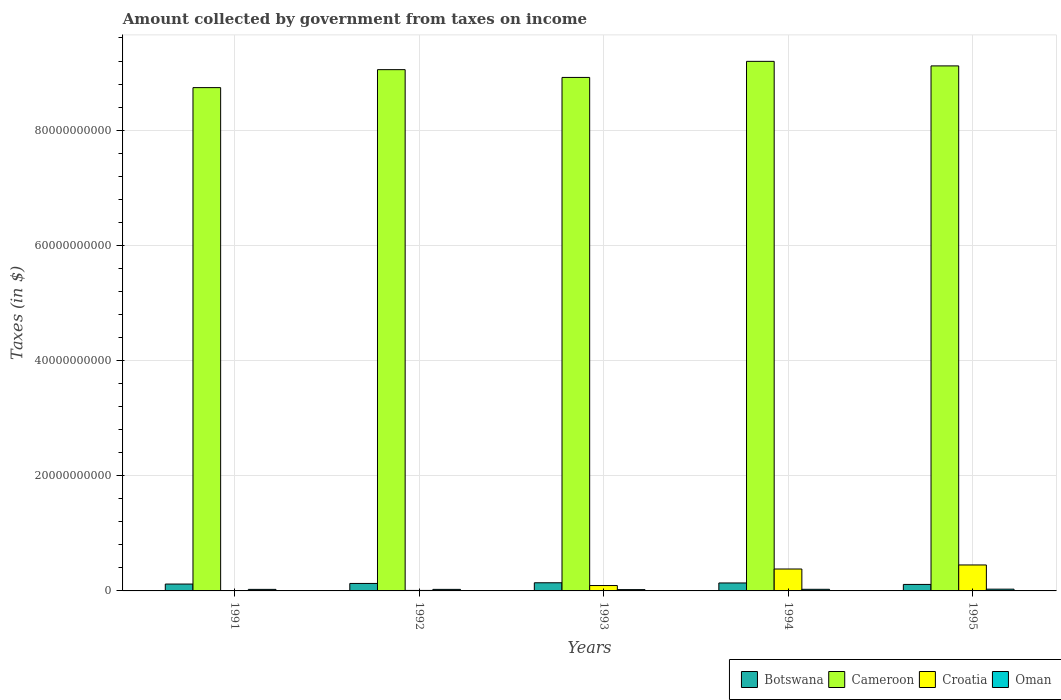How many different coloured bars are there?
Give a very brief answer. 4. Are the number of bars on each tick of the X-axis equal?
Provide a succinct answer. Yes. What is the label of the 1st group of bars from the left?
Ensure brevity in your answer.  1991. In how many cases, is the number of bars for a given year not equal to the number of legend labels?
Provide a short and direct response. 0. What is the amount collected by government from taxes on income in Cameroon in 1995?
Provide a short and direct response. 9.12e+1. Across all years, what is the maximum amount collected by government from taxes on income in Croatia?
Your response must be concise. 4.51e+09. Across all years, what is the minimum amount collected by government from taxes on income in Croatia?
Your answer should be very brief. 2.45e+07. In which year was the amount collected by government from taxes on income in Croatia maximum?
Provide a succinct answer. 1995. In which year was the amount collected by government from taxes on income in Cameroon minimum?
Offer a very short reply. 1991. What is the total amount collected by government from taxes on income in Botswana in the graph?
Offer a very short reply. 6.41e+09. What is the difference between the amount collected by government from taxes on income in Botswana in 1991 and that in 1994?
Provide a succinct answer. -1.90e+08. What is the difference between the amount collected by government from taxes on income in Croatia in 1993 and the amount collected by government from taxes on income in Cameroon in 1995?
Keep it short and to the point. -9.02e+1. What is the average amount collected by government from taxes on income in Oman per year?
Give a very brief answer. 2.70e+08. In the year 1992, what is the difference between the amount collected by government from taxes on income in Botswana and amount collected by government from taxes on income in Cameroon?
Your answer should be very brief. -8.92e+1. In how many years, is the amount collected by government from taxes on income in Cameroon greater than 12000000000 $?
Your answer should be very brief. 5. What is the ratio of the amount collected by government from taxes on income in Oman in 1992 to that in 1993?
Provide a succinct answer. 1.18. Is the difference between the amount collected by government from taxes on income in Botswana in 1992 and 1993 greater than the difference between the amount collected by government from taxes on income in Cameroon in 1992 and 1993?
Offer a terse response. No. What is the difference between the highest and the second highest amount collected by government from taxes on income in Oman?
Offer a terse response. 2.39e+07. What is the difference between the highest and the lowest amount collected by government from taxes on income in Botswana?
Make the answer very short. 2.88e+08. In how many years, is the amount collected by government from taxes on income in Botswana greater than the average amount collected by government from taxes on income in Botswana taken over all years?
Provide a succinct answer. 3. Is the sum of the amount collected by government from taxes on income in Botswana in 1992 and 1994 greater than the maximum amount collected by government from taxes on income in Cameroon across all years?
Give a very brief answer. No. What does the 4th bar from the left in 1991 represents?
Your answer should be compact. Oman. What does the 3rd bar from the right in 1995 represents?
Your response must be concise. Cameroon. Are all the bars in the graph horizontal?
Offer a terse response. No. How many years are there in the graph?
Offer a very short reply. 5. Are the values on the major ticks of Y-axis written in scientific E-notation?
Make the answer very short. No. Does the graph contain grids?
Offer a very short reply. Yes. How many legend labels are there?
Ensure brevity in your answer.  4. How are the legend labels stacked?
Make the answer very short. Horizontal. What is the title of the graph?
Make the answer very short. Amount collected by government from taxes on income. Does "Greece" appear as one of the legend labels in the graph?
Your answer should be compact. No. What is the label or title of the Y-axis?
Offer a very short reply. Taxes (in $). What is the Taxes (in $) in Botswana in 1991?
Keep it short and to the point. 1.19e+09. What is the Taxes (in $) of Cameroon in 1991?
Provide a short and direct response. 8.74e+1. What is the Taxes (in $) in Croatia in 1991?
Provide a short and direct response. 2.45e+07. What is the Taxes (in $) of Oman in 1991?
Offer a terse response. 2.67e+08. What is the Taxes (in $) in Botswana in 1992?
Offer a terse response. 1.30e+09. What is the Taxes (in $) in Cameroon in 1992?
Provide a succinct answer. 9.05e+1. What is the Taxes (in $) in Croatia in 1992?
Make the answer very short. 8.40e+07. What is the Taxes (in $) in Oman in 1992?
Provide a short and direct response. 2.67e+08. What is the Taxes (in $) in Botswana in 1993?
Keep it short and to the point. 1.42e+09. What is the Taxes (in $) in Cameroon in 1993?
Your answer should be very brief. 8.92e+1. What is the Taxes (in $) in Croatia in 1993?
Give a very brief answer. 9.36e+08. What is the Taxes (in $) in Oman in 1993?
Keep it short and to the point. 2.27e+08. What is the Taxes (in $) of Botswana in 1994?
Ensure brevity in your answer.  1.38e+09. What is the Taxes (in $) of Cameroon in 1994?
Give a very brief answer. 9.19e+1. What is the Taxes (in $) in Croatia in 1994?
Keep it short and to the point. 3.80e+09. What is the Taxes (in $) of Oman in 1994?
Keep it short and to the point. 2.82e+08. What is the Taxes (in $) in Botswana in 1995?
Provide a succinct answer. 1.13e+09. What is the Taxes (in $) of Cameroon in 1995?
Give a very brief answer. 9.12e+1. What is the Taxes (in $) of Croatia in 1995?
Provide a succinct answer. 4.51e+09. What is the Taxes (in $) in Oman in 1995?
Your response must be concise. 3.06e+08. Across all years, what is the maximum Taxes (in $) in Botswana?
Keep it short and to the point. 1.42e+09. Across all years, what is the maximum Taxes (in $) of Cameroon?
Keep it short and to the point. 9.19e+1. Across all years, what is the maximum Taxes (in $) of Croatia?
Ensure brevity in your answer.  4.51e+09. Across all years, what is the maximum Taxes (in $) of Oman?
Provide a short and direct response. 3.06e+08. Across all years, what is the minimum Taxes (in $) of Botswana?
Your answer should be compact. 1.13e+09. Across all years, what is the minimum Taxes (in $) of Cameroon?
Offer a terse response. 8.74e+1. Across all years, what is the minimum Taxes (in $) in Croatia?
Your response must be concise. 2.45e+07. Across all years, what is the minimum Taxes (in $) of Oman?
Offer a very short reply. 2.27e+08. What is the total Taxes (in $) in Botswana in the graph?
Ensure brevity in your answer.  6.41e+09. What is the total Taxes (in $) of Cameroon in the graph?
Give a very brief answer. 4.50e+11. What is the total Taxes (in $) in Croatia in the graph?
Keep it short and to the point. 9.35e+09. What is the total Taxes (in $) of Oman in the graph?
Make the answer very short. 1.35e+09. What is the difference between the Taxes (in $) in Botswana in 1991 and that in 1992?
Offer a very short reply. -1.07e+08. What is the difference between the Taxes (in $) in Cameroon in 1991 and that in 1992?
Offer a very short reply. -3.12e+09. What is the difference between the Taxes (in $) in Croatia in 1991 and that in 1992?
Keep it short and to the point. -5.95e+07. What is the difference between the Taxes (in $) of Oman in 1991 and that in 1992?
Provide a succinct answer. 2.00e+05. What is the difference between the Taxes (in $) in Botswana in 1991 and that in 1993?
Offer a very short reply. -2.24e+08. What is the difference between the Taxes (in $) in Cameroon in 1991 and that in 1993?
Provide a succinct answer. -1.77e+09. What is the difference between the Taxes (in $) of Croatia in 1991 and that in 1993?
Make the answer very short. -9.11e+08. What is the difference between the Taxes (in $) in Oman in 1991 and that in 1993?
Give a very brief answer. 4.00e+07. What is the difference between the Taxes (in $) in Botswana in 1991 and that in 1994?
Provide a short and direct response. -1.90e+08. What is the difference between the Taxes (in $) of Cameroon in 1991 and that in 1994?
Offer a very short reply. -4.56e+09. What is the difference between the Taxes (in $) in Croatia in 1991 and that in 1994?
Keep it short and to the point. -3.78e+09. What is the difference between the Taxes (in $) in Oman in 1991 and that in 1994?
Make the answer very short. -1.43e+07. What is the difference between the Taxes (in $) in Botswana in 1991 and that in 1995?
Keep it short and to the point. 6.38e+07. What is the difference between the Taxes (in $) of Cameroon in 1991 and that in 1995?
Keep it short and to the point. -3.77e+09. What is the difference between the Taxes (in $) of Croatia in 1991 and that in 1995?
Your response must be concise. -4.48e+09. What is the difference between the Taxes (in $) of Oman in 1991 and that in 1995?
Give a very brief answer. -3.82e+07. What is the difference between the Taxes (in $) of Botswana in 1992 and that in 1993?
Ensure brevity in your answer.  -1.18e+08. What is the difference between the Taxes (in $) in Cameroon in 1992 and that in 1993?
Your answer should be very brief. 1.35e+09. What is the difference between the Taxes (in $) of Croatia in 1992 and that in 1993?
Provide a short and direct response. -8.52e+08. What is the difference between the Taxes (in $) in Oman in 1992 and that in 1993?
Your response must be concise. 3.98e+07. What is the difference between the Taxes (in $) of Botswana in 1992 and that in 1994?
Provide a succinct answer. -8.36e+07. What is the difference between the Taxes (in $) of Cameroon in 1992 and that in 1994?
Ensure brevity in your answer.  -1.44e+09. What is the difference between the Taxes (in $) in Croatia in 1992 and that in 1994?
Your response must be concise. -3.72e+09. What is the difference between the Taxes (in $) of Oman in 1992 and that in 1994?
Ensure brevity in your answer.  -1.45e+07. What is the difference between the Taxes (in $) in Botswana in 1992 and that in 1995?
Give a very brief answer. 1.70e+08. What is the difference between the Taxes (in $) of Cameroon in 1992 and that in 1995?
Give a very brief answer. -6.50e+08. What is the difference between the Taxes (in $) of Croatia in 1992 and that in 1995?
Keep it short and to the point. -4.42e+09. What is the difference between the Taxes (in $) of Oman in 1992 and that in 1995?
Offer a very short reply. -3.84e+07. What is the difference between the Taxes (in $) in Botswana in 1993 and that in 1994?
Your answer should be very brief. 3.42e+07. What is the difference between the Taxes (in $) of Cameroon in 1993 and that in 1994?
Make the answer very short. -2.79e+09. What is the difference between the Taxes (in $) of Croatia in 1993 and that in 1994?
Your answer should be very brief. -2.87e+09. What is the difference between the Taxes (in $) in Oman in 1993 and that in 1994?
Ensure brevity in your answer.  -5.43e+07. What is the difference between the Taxes (in $) of Botswana in 1993 and that in 1995?
Your answer should be compact. 2.88e+08. What is the difference between the Taxes (in $) of Cameroon in 1993 and that in 1995?
Ensure brevity in your answer.  -2.00e+09. What is the difference between the Taxes (in $) of Croatia in 1993 and that in 1995?
Ensure brevity in your answer.  -3.57e+09. What is the difference between the Taxes (in $) of Oman in 1993 and that in 1995?
Give a very brief answer. -7.82e+07. What is the difference between the Taxes (in $) in Botswana in 1994 and that in 1995?
Make the answer very short. 2.54e+08. What is the difference between the Taxes (in $) in Cameroon in 1994 and that in 1995?
Provide a short and direct response. 7.90e+08. What is the difference between the Taxes (in $) in Croatia in 1994 and that in 1995?
Your answer should be very brief. -7.03e+08. What is the difference between the Taxes (in $) in Oman in 1994 and that in 1995?
Provide a succinct answer. -2.39e+07. What is the difference between the Taxes (in $) of Botswana in 1991 and the Taxes (in $) of Cameroon in 1992?
Keep it short and to the point. -8.93e+1. What is the difference between the Taxes (in $) in Botswana in 1991 and the Taxes (in $) in Croatia in 1992?
Make the answer very short. 1.11e+09. What is the difference between the Taxes (in $) of Botswana in 1991 and the Taxes (in $) of Oman in 1992?
Your answer should be compact. 9.24e+08. What is the difference between the Taxes (in $) of Cameroon in 1991 and the Taxes (in $) of Croatia in 1992?
Your response must be concise. 8.73e+1. What is the difference between the Taxes (in $) in Cameroon in 1991 and the Taxes (in $) in Oman in 1992?
Your answer should be compact. 8.71e+1. What is the difference between the Taxes (in $) of Croatia in 1991 and the Taxes (in $) of Oman in 1992?
Your answer should be very brief. -2.43e+08. What is the difference between the Taxes (in $) of Botswana in 1991 and the Taxes (in $) of Cameroon in 1993?
Keep it short and to the point. -8.80e+1. What is the difference between the Taxes (in $) in Botswana in 1991 and the Taxes (in $) in Croatia in 1993?
Ensure brevity in your answer.  2.55e+08. What is the difference between the Taxes (in $) of Botswana in 1991 and the Taxes (in $) of Oman in 1993?
Offer a terse response. 9.64e+08. What is the difference between the Taxes (in $) in Cameroon in 1991 and the Taxes (in $) in Croatia in 1993?
Your response must be concise. 8.64e+1. What is the difference between the Taxes (in $) of Cameroon in 1991 and the Taxes (in $) of Oman in 1993?
Give a very brief answer. 8.72e+1. What is the difference between the Taxes (in $) in Croatia in 1991 and the Taxes (in $) in Oman in 1993?
Ensure brevity in your answer.  -2.03e+08. What is the difference between the Taxes (in $) in Botswana in 1991 and the Taxes (in $) in Cameroon in 1994?
Provide a short and direct response. -9.07e+1. What is the difference between the Taxes (in $) in Botswana in 1991 and the Taxes (in $) in Croatia in 1994?
Make the answer very short. -2.61e+09. What is the difference between the Taxes (in $) in Botswana in 1991 and the Taxes (in $) in Oman in 1994?
Your response must be concise. 9.09e+08. What is the difference between the Taxes (in $) in Cameroon in 1991 and the Taxes (in $) in Croatia in 1994?
Your answer should be compact. 8.36e+1. What is the difference between the Taxes (in $) in Cameroon in 1991 and the Taxes (in $) in Oman in 1994?
Make the answer very short. 8.71e+1. What is the difference between the Taxes (in $) of Croatia in 1991 and the Taxes (in $) of Oman in 1994?
Give a very brief answer. -2.57e+08. What is the difference between the Taxes (in $) of Botswana in 1991 and the Taxes (in $) of Cameroon in 1995?
Your answer should be very brief. -9.00e+1. What is the difference between the Taxes (in $) of Botswana in 1991 and the Taxes (in $) of Croatia in 1995?
Offer a terse response. -3.32e+09. What is the difference between the Taxes (in $) of Botswana in 1991 and the Taxes (in $) of Oman in 1995?
Ensure brevity in your answer.  8.85e+08. What is the difference between the Taxes (in $) in Cameroon in 1991 and the Taxes (in $) in Croatia in 1995?
Offer a very short reply. 8.29e+1. What is the difference between the Taxes (in $) in Cameroon in 1991 and the Taxes (in $) in Oman in 1995?
Your response must be concise. 8.71e+1. What is the difference between the Taxes (in $) in Croatia in 1991 and the Taxes (in $) in Oman in 1995?
Offer a terse response. -2.81e+08. What is the difference between the Taxes (in $) of Botswana in 1992 and the Taxes (in $) of Cameroon in 1993?
Make the answer very short. -8.79e+1. What is the difference between the Taxes (in $) in Botswana in 1992 and the Taxes (in $) in Croatia in 1993?
Give a very brief answer. 3.62e+08. What is the difference between the Taxes (in $) of Botswana in 1992 and the Taxes (in $) of Oman in 1993?
Your response must be concise. 1.07e+09. What is the difference between the Taxes (in $) in Cameroon in 1992 and the Taxes (in $) in Croatia in 1993?
Provide a succinct answer. 8.96e+1. What is the difference between the Taxes (in $) of Cameroon in 1992 and the Taxes (in $) of Oman in 1993?
Offer a terse response. 9.03e+1. What is the difference between the Taxes (in $) in Croatia in 1992 and the Taxes (in $) in Oman in 1993?
Make the answer very short. -1.43e+08. What is the difference between the Taxes (in $) of Botswana in 1992 and the Taxes (in $) of Cameroon in 1994?
Make the answer very short. -9.06e+1. What is the difference between the Taxes (in $) of Botswana in 1992 and the Taxes (in $) of Croatia in 1994?
Make the answer very short. -2.51e+09. What is the difference between the Taxes (in $) in Botswana in 1992 and the Taxes (in $) in Oman in 1994?
Ensure brevity in your answer.  1.02e+09. What is the difference between the Taxes (in $) of Cameroon in 1992 and the Taxes (in $) of Croatia in 1994?
Make the answer very short. 8.67e+1. What is the difference between the Taxes (in $) in Cameroon in 1992 and the Taxes (in $) in Oman in 1994?
Give a very brief answer. 9.02e+1. What is the difference between the Taxes (in $) in Croatia in 1992 and the Taxes (in $) in Oman in 1994?
Your response must be concise. -1.98e+08. What is the difference between the Taxes (in $) of Botswana in 1992 and the Taxes (in $) of Cameroon in 1995?
Provide a succinct answer. -8.99e+1. What is the difference between the Taxes (in $) in Botswana in 1992 and the Taxes (in $) in Croatia in 1995?
Your response must be concise. -3.21e+09. What is the difference between the Taxes (in $) of Botswana in 1992 and the Taxes (in $) of Oman in 1995?
Offer a terse response. 9.92e+08. What is the difference between the Taxes (in $) of Cameroon in 1992 and the Taxes (in $) of Croatia in 1995?
Provide a succinct answer. 8.60e+1. What is the difference between the Taxes (in $) in Cameroon in 1992 and the Taxes (in $) in Oman in 1995?
Offer a very short reply. 9.02e+1. What is the difference between the Taxes (in $) of Croatia in 1992 and the Taxes (in $) of Oman in 1995?
Give a very brief answer. -2.22e+08. What is the difference between the Taxes (in $) in Botswana in 1993 and the Taxes (in $) in Cameroon in 1994?
Your answer should be compact. -9.05e+1. What is the difference between the Taxes (in $) of Botswana in 1993 and the Taxes (in $) of Croatia in 1994?
Give a very brief answer. -2.39e+09. What is the difference between the Taxes (in $) of Botswana in 1993 and the Taxes (in $) of Oman in 1994?
Provide a short and direct response. 1.13e+09. What is the difference between the Taxes (in $) in Cameroon in 1993 and the Taxes (in $) in Croatia in 1994?
Ensure brevity in your answer.  8.53e+1. What is the difference between the Taxes (in $) in Cameroon in 1993 and the Taxes (in $) in Oman in 1994?
Offer a terse response. 8.89e+1. What is the difference between the Taxes (in $) of Croatia in 1993 and the Taxes (in $) of Oman in 1994?
Your answer should be compact. 6.54e+08. What is the difference between the Taxes (in $) of Botswana in 1993 and the Taxes (in $) of Cameroon in 1995?
Your response must be concise. -8.97e+1. What is the difference between the Taxes (in $) in Botswana in 1993 and the Taxes (in $) in Croatia in 1995?
Your answer should be very brief. -3.09e+09. What is the difference between the Taxes (in $) in Botswana in 1993 and the Taxes (in $) in Oman in 1995?
Your response must be concise. 1.11e+09. What is the difference between the Taxes (in $) of Cameroon in 1993 and the Taxes (in $) of Croatia in 1995?
Make the answer very short. 8.46e+1. What is the difference between the Taxes (in $) in Cameroon in 1993 and the Taxes (in $) in Oman in 1995?
Offer a very short reply. 8.88e+1. What is the difference between the Taxes (in $) in Croatia in 1993 and the Taxes (in $) in Oman in 1995?
Provide a succinct answer. 6.30e+08. What is the difference between the Taxes (in $) of Botswana in 1994 and the Taxes (in $) of Cameroon in 1995?
Your answer should be compact. -8.98e+1. What is the difference between the Taxes (in $) in Botswana in 1994 and the Taxes (in $) in Croatia in 1995?
Ensure brevity in your answer.  -3.13e+09. What is the difference between the Taxes (in $) in Botswana in 1994 and the Taxes (in $) in Oman in 1995?
Provide a short and direct response. 1.08e+09. What is the difference between the Taxes (in $) in Cameroon in 1994 and the Taxes (in $) in Croatia in 1995?
Provide a short and direct response. 8.74e+1. What is the difference between the Taxes (in $) in Cameroon in 1994 and the Taxes (in $) in Oman in 1995?
Your answer should be very brief. 9.16e+1. What is the difference between the Taxes (in $) in Croatia in 1994 and the Taxes (in $) in Oman in 1995?
Make the answer very short. 3.50e+09. What is the average Taxes (in $) of Botswana per year?
Give a very brief answer. 1.28e+09. What is the average Taxes (in $) of Cameroon per year?
Provide a short and direct response. 9.00e+1. What is the average Taxes (in $) of Croatia per year?
Offer a very short reply. 1.87e+09. What is the average Taxes (in $) in Oman per year?
Make the answer very short. 2.70e+08. In the year 1991, what is the difference between the Taxes (in $) in Botswana and Taxes (in $) in Cameroon?
Provide a succinct answer. -8.62e+1. In the year 1991, what is the difference between the Taxes (in $) in Botswana and Taxes (in $) in Croatia?
Your answer should be very brief. 1.17e+09. In the year 1991, what is the difference between the Taxes (in $) of Botswana and Taxes (in $) of Oman?
Provide a short and direct response. 9.24e+08. In the year 1991, what is the difference between the Taxes (in $) of Cameroon and Taxes (in $) of Croatia?
Give a very brief answer. 8.74e+1. In the year 1991, what is the difference between the Taxes (in $) in Cameroon and Taxes (in $) in Oman?
Your answer should be very brief. 8.71e+1. In the year 1991, what is the difference between the Taxes (in $) in Croatia and Taxes (in $) in Oman?
Provide a short and direct response. -2.43e+08. In the year 1992, what is the difference between the Taxes (in $) in Botswana and Taxes (in $) in Cameroon?
Give a very brief answer. -8.92e+1. In the year 1992, what is the difference between the Taxes (in $) in Botswana and Taxes (in $) in Croatia?
Provide a short and direct response. 1.21e+09. In the year 1992, what is the difference between the Taxes (in $) in Botswana and Taxes (in $) in Oman?
Your answer should be compact. 1.03e+09. In the year 1992, what is the difference between the Taxes (in $) in Cameroon and Taxes (in $) in Croatia?
Your answer should be compact. 9.04e+1. In the year 1992, what is the difference between the Taxes (in $) in Cameroon and Taxes (in $) in Oman?
Your answer should be very brief. 9.02e+1. In the year 1992, what is the difference between the Taxes (in $) in Croatia and Taxes (in $) in Oman?
Your response must be concise. -1.83e+08. In the year 1993, what is the difference between the Taxes (in $) in Botswana and Taxes (in $) in Cameroon?
Your answer should be compact. -8.77e+1. In the year 1993, what is the difference between the Taxes (in $) in Botswana and Taxes (in $) in Croatia?
Ensure brevity in your answer.  4.80e+08. In the year 1993, what is the difference between the Taxes (in $) of Botswana and Taxes (in $) of Oman?
Provide a succinct answer. 1.19e+09. In the year 1993, what is the difference between the Taxes (in $) in Cameroon and Taxes (in $) in Croatia?
Your answer should be very brief. 8.82e+1. In the year 1993, what is the difference between the Taxes (in $) in Cameroon and Taxes (in $) in Oman?
Ensure brevity in your answer.  8.89e+1. In the year 1993, what is the difference between the Taxes (in $) in Croatia and Taxes (in $) in Oman?
Ensure brevity in your answer.  7.08e+08. In the year 1994, what is the difference between the Taxes (in $) in Botswana and Taxes (in $) in Cameroon?
Ensure brevity in your answer.  -9.06e+1. In the year 1994, what is the difference between the Taxes (in $) of Botswana and Taxes (in $) of Croatia?
Offer a very short reply. -2.42e+09. In the year 1994, what is the difference between the Taxes (in $) in Botswana and Taxes (in $) in Oman?
Your answer should be very brief. 1.10e+09. In the year 1994, what is the difference between the Taxes (in $) of Cameroon and Taxes (in $) of Croatia?
Provide a succinct answer. 8.81e+1. In the year 1994, what is the difference between the Taxes (in $) of Cameroon and Taxes (in $) of Oman?
Provide a succinct answer. 9.17e+1. In the year 1994, what is the difference between the Taxes (in $) of Croatia and Taxes (in $) of Oman?
Offer a terse response. 3.52e+09. In the year 1995, what is the difference between the Taxes (in $) in Botswana and Taxes (in $) in Cameroon?
Ensure brevity in your answer.  -9.00e+1. In the year 1995, what is the difference between the Taxes (in $) of Botswana and Taxes (in $) of Croatia?
Offer a very short reply. -3.38e+09. In the year 1995, what is the difference between the Taxes (in $) in Botswana and Taxes (in $) in Oman?
Your answer should be very brief. 8.22e+08. In the year 1995, what is the difference between the Taxes (in $) of Cameroon and Taxes (in $) of Croatia?
Offer a terse response. 8.66e+1. In the year 1995, what is the difference between the Taxes (in $) of Cameroon and Taxes (in $) of Oman?
Ensure brevity in your answer.  9.08e+1. In the year 1995, what is the difference between the Taxes (in $) in Croatia and Taxes (in $) in Oman?
Offer a terse response. 4.20e+09. What is the ratio of the Taxes (in $) in Botswana in 1991 to that in 1992?
Provide a succinct answer. 0.92. What is the ratio of the Taxes (in $) of Cameroon in 1991 to that in 1992?
Your answer should be compact. 0.97. What is the ratio of the Taxes (in $) of Croatia in 1991 to that in 1992?
Provide a succinct answer. 0.29. What is the ratio of the Taxes (in $) in Oman in 1991 to that in 1992?
Ensure brevity in your answer.  1. What is the ratio of the Taxes (in $) in Botswana in 1991 to that in 1993?
Offer a very short reply. 0.84. What is the ratio of the Taxes (in $) in Cameroon in 1991 to that in 1993?
Offer a terse response. 0.98. What is the ratio of the Taxes (in $) in Croatia in 1991 to that in 1993?
Provide a succinct answer. 0.03. What is the ratio of the Taxes (in $) in Oman in 1991 to that in 1993?
Offer a very short reply. 1.18. What is the ratio of the Taxes (in $) in Botswana in 1991 to that in 1994?
Provide a short and direct response. 0.86. What is the ratio of the Taxes (in $) of Cameroon in 1991 to that in 1994?
Your response must be concise. 0.95. What is the ratio of the Taxes (in $) in Croatia in 1991 to that in 1994?
Your answer should be compact. 0.01. What is the ratio of the Taxes (in $) in Oman in 1991 to that in 1994?
Your response must be concise. 0.95. What is the ratio of the Taxes (in $) in Botswana in 1991 to that in 1995?
Offer a terse response. 1.06. What is the ratio of the Taxes (in $) in Cameroon in 1991 to that in 1995?
Offer a very short reply. 0.96. What is the ratio of the Taxes (in $) of Croatia in 1991 to that in 1995?
Provide a succinct answer. 0.01. What is the ratio of the Taxes (in $) of Botswana in 1992 to that in 1993?
Your response must be concise. 0.92. What is the ratio of the Taxes (in $) of Cameroon in 1992 to that in 1993?
Your answer should be compact. 1.02. What is the ratio of the Taxes (in $) in Croatia in 1992 to that in 1993?
Your answer should be very brief. 0.09. What is the ratio of the Taxes (in $) in Oman in 1992 to that in 1993?
Your answer should be compact. 1.18. What is the ratio of the Taxes (in $) of Botswana in 1992 to that in 1994?
Provide a succinct answer. 0.94. What is the ratio of the Taxes (in $) in Cameroon in 1992 to that in 1994?
Offer a very short reply. 0.98. What is the ratio of the Taxes (in $) of Croatia in 1992 to that in 1994?
Provide a succinct answer. 0.02. What is the ratio of the Taxes (in $) of Oman in 1992 to that in 1994?
Offer a terse response. 0.95. What is the ratio of the Taxes (in $) in Botswana in 1992 to that in 1995?
Provide a succinct answer. 1.15. What is the ratio of the Taxes (in $) in Croatia in 1992 to that in 1995?
Offer a terse response. 0.02. What is the ratio of the Taxes (in $) in Oman in 1992 to that in 1995?
Keep it short and to the point. 0.87. What is the ratio of the Taxes (in $) of Botswana in 1993 to that in 1994?
Your answer should be compact. 1.02. What is the ratio of the Taxes (in $) in Cameroon in 1993 to that in 1994?
Ensure brevity in your answer.  0.97. What is the ratio of the Taxes (in $) in Croatia in 1993 to that in 1994?
Your response must be concise. 0.25. What is the ratio of the Taxes (in $) in Oman in 1993 to that in 1994?
Give a very brief answer. 0.81. What is the ratio of the Taxes (in $) in Botswana in 1993 to that in 1995?
Ensure brevity in your answer.  1.26. What is the ratio of the Taxes (in $) of Cameroon in 1993 to that in 1995?
Make the answer very short. 0.98. What is the ratio of the Taxes (in $) in Croatia in 1993 to that in 1995?
Ensure brevity in your answer.  0.21. What is the ratio of the Taxes (in $) of Oman in 1993 to that in 1995?
Make the answer very short. 0.74. What is the ratio of the Taxes (in $) in Botswana in 1994 to that in 1995?
Keep it short and to the point. 1.23. What is the ratio of the Taxes (in $) in Cameroon in 1994 to that in 1995?
Provide a succinct answer. 1.01. What is the ratio of the Taxes (in $) of Croatia in 1994 to that in 1995?
Provide a short and direct response. 0.84. What is the ratio of the Taxes (in $) of Oman in 1994 to that in 1995?
Ensure brevity in your answer.  0.92. What is the difference between the highest and the second highest Taxes (in $) of Botswana?
Your answer should be very brief. 3.42e+07. What is the difference between the highest and the second highest Taxes (in $) of Cameroon?
Provide a short and direct response. 7.90e+08. What is the difference between the highest and the second highest Taxes (in $) in Croatia?
Ensure brevity in your answer.  7.03e+08. What is the difference between the highest and the second highest Taxes (in $) of Oman?
Provide a succinct answer. 2.39e+07. What is the difference between the highest and the lowest Taxes (in $) of Botswana?
Offer a very short reply. 2.88e+08. What is the difference between the highest and the lowest Taxes (in $) of Cameroon?
Your answer should be very brief. 4.56e+09. What is the difference between the highest and the lowest Taxes (in $) in Croatia?
Your answer should be very brief. 4.48e+09. What is the difference between the highest and the lowest Taxes (in $) in Oman?
Provide a succinct answer. 7.82e+07. 